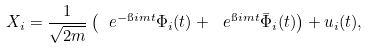<formula> <loc_0><loc_0><loc_500><loc_500>X _ { i } = \frac { 1 } { \sqrt { 2 m } } \left ( \ e ^ { - \i i m t } \Phi _ { i } ( t ) + \ e ^ { \i i m t } \bar { \Phi } _ { i } ( t ) \right ) + u _ { i } ( t ) ,</formula> 